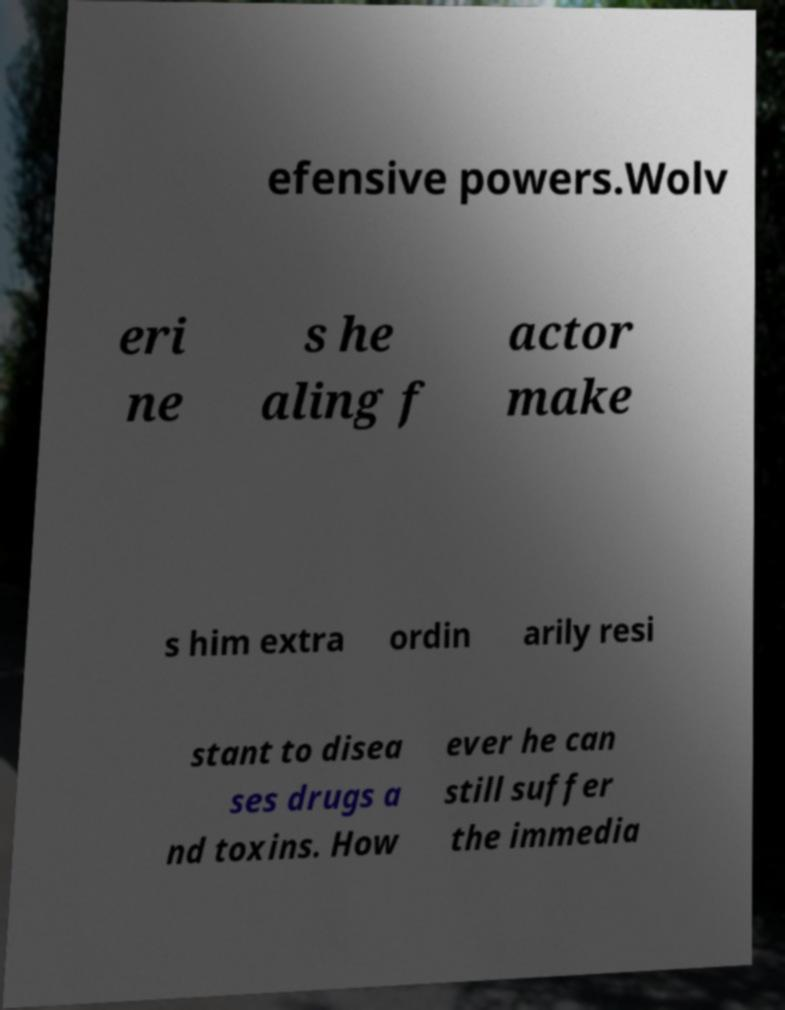Can you read and provide the text displayed in the image?This photo seems to have some interesting text. Can you extract and type it out for me? efensive powers.Wolv eri ne s he aling f actor make s him extra ordin arily resi stant to disea ses drugs a nd toxins. How ever he can still suffer the immedia 